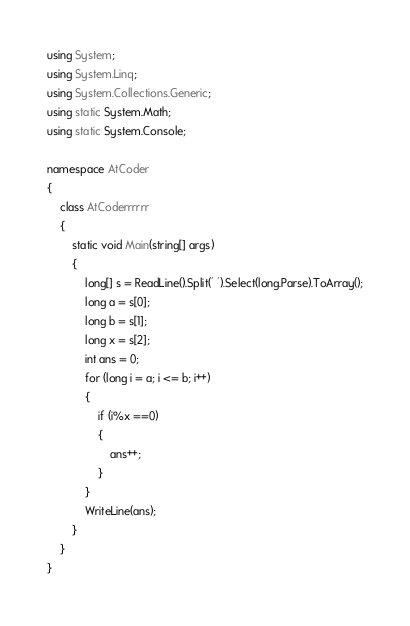<code> <loc_0><loc_0><loc_500><loc_500><_C#_>using System;
using System.Linq;
using System.Collections.Generic;
using static System.Math;
using static System.Console;

namespace AtCoder
{
    class AtCoderrrrrr
    {
        static void Main(string[] args)
        {
            long[] s = ReadLine().Split(' ').Select(long.Parse).ToArray();
            long a = s[0];
            long b = s[1];
            long x = s[2];
            int ans = 0;
            for (long i = a; i <= b; i++)
            {
                if (i%x ==0)
                {
                    ans++;
                }
            }
            WriteLine(ans);
        }
    }
}
</code> 